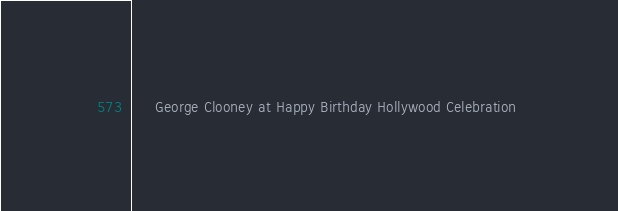<code> <loc_0><loc_0><loc_500><loc_500><_XML_>	 George Clooney at Happy Birthday Hollywood Celebration 
</code> 